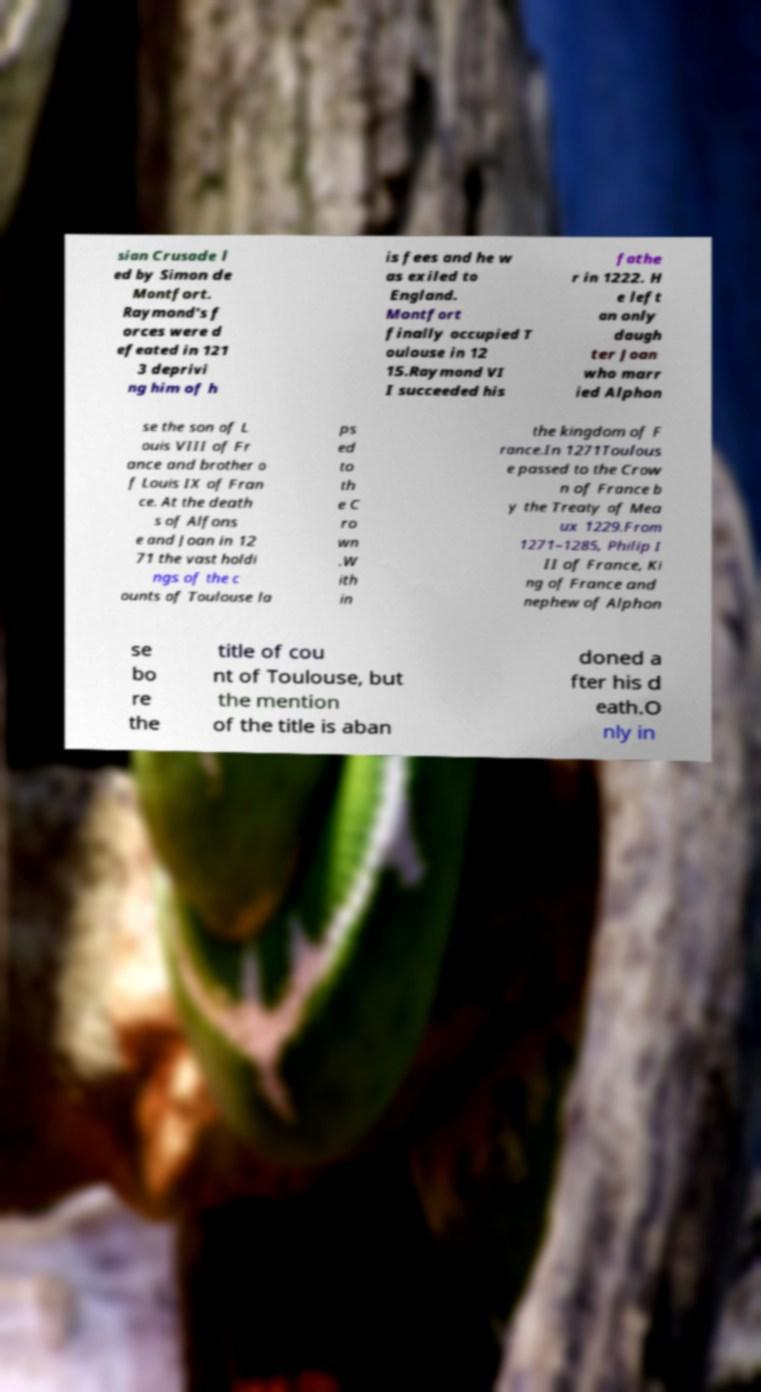Can you read and provide the text displayed in the image?This photo seems to have some interesting text. Can you extract and type it out for me? sian Crusade l ed by Simon de Montfort. Raymond's f orces were d efeated in 121 3 deprivi ng him of h is fees and he w as exiled to England. Montfort finally occupied T oulouse in 12 15.Raymond VI I succeeded his fathe r in 1222. H e left an only daugh ter Joan who marr ied Alphon se the son of L ouis VIII of Fr ance and brother o f Louis IX of Fran ce. At the death s of Alfons e and Joan in 12 71 the vast holdi ngs of the c ounts of Toulouse la ps ed to th e C ro wn .W ith in the kingdom of F rance.In 1271Toulous e passed to the Crow n of France b y the Treaty of Mea ux 1229.From 1271–1285, Philip I II of France, Ki ng of France and nephew of Alphon se bo re the title of cou nt of Toulouse, but the mention of the title is aban doned a fter his d eath.O nly in 